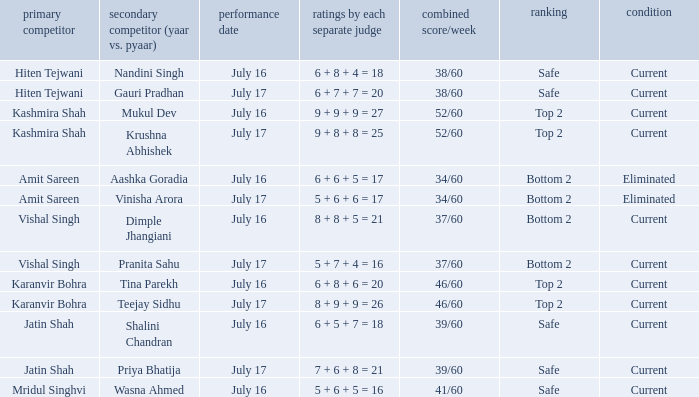Write the full table. {'header': ['primary competitor', 'secondary competitor (yaar vs. pyaar)', 'performance date', 'ratings by each separate judge', 'combined score/week', 'ranking', 'condition'], 'rows': [['Hiten Tejwani', 'Nandini Singh', 'July 16', '6 + 8 + 4 = 18', '38/60', 'Safe', 'Current'], ['Hiten Tejwani', 'Gauri Pradhan', 'July 17', '6 + 7 + 7 = 20', '38/60', 'Safe', 'Current'], ['Kashmira Shah', 'Mukul Dev', 'July 16', '9 + 9 + 9 = 27', '52/60', 'Top 2', 'Current'], ['Kashmira Shah', 'Krushna Abhishek', 'July 17', '9 + 8 + 8 = 25', '52/60', 'Top 2', 'Current'], ['Amit Sareen', 'Aashka Goradia', 'July 16', '6 + 6 + 5 = 17', '34/60', 'Bottom 2', 'Eliminated'], ['Amit Sareen', 'Vinisha Arora', 'July 17', '5 + 6 + 6 = 17', '34/60', 'Bottom 2', 'Eliminated'], ['Vishal Singh', 'Dimple Jhangiani', 'July 16', '8 + 8 + 5 = 21', '37/60', 'Bottom 2', 'Current'], ['Vishal Singh', 'Pranita Sahu', 'July 17', '5 + 7 + 4 = 16', '37/60', 'Bottom 2', 'Current'], ['Karanvir Bohra', 'Tina Parekh', 'July 16', '6 + 8 + 6 = 20', '46/60', 'Top 2', 'Current'], ['Karanvir Bohra', 'Teejay Sidhu', 'July 17', '8 + 9 + 9 = 26', '46/60', 'Top 2', 'Current'], ['Jatin Shah', 'Shalini Chandran', 'July 16', '6 + 5 + 7 = 18', '39/60', 'Safe', 'Current'], ['Jatin Shah', 'Priya Bhatija', 'July 17', '7 + 6 + 8 = 21', '39/60', 'Safe', 'Current'], ['Mridul Singhvi', 'Wasna Ahmed', 'July 16', '5 + 6 + 5 = 16', '41/60', 'Safe', 'Current']]} What position did Pranita Sahu's team get? Bottom 2. 